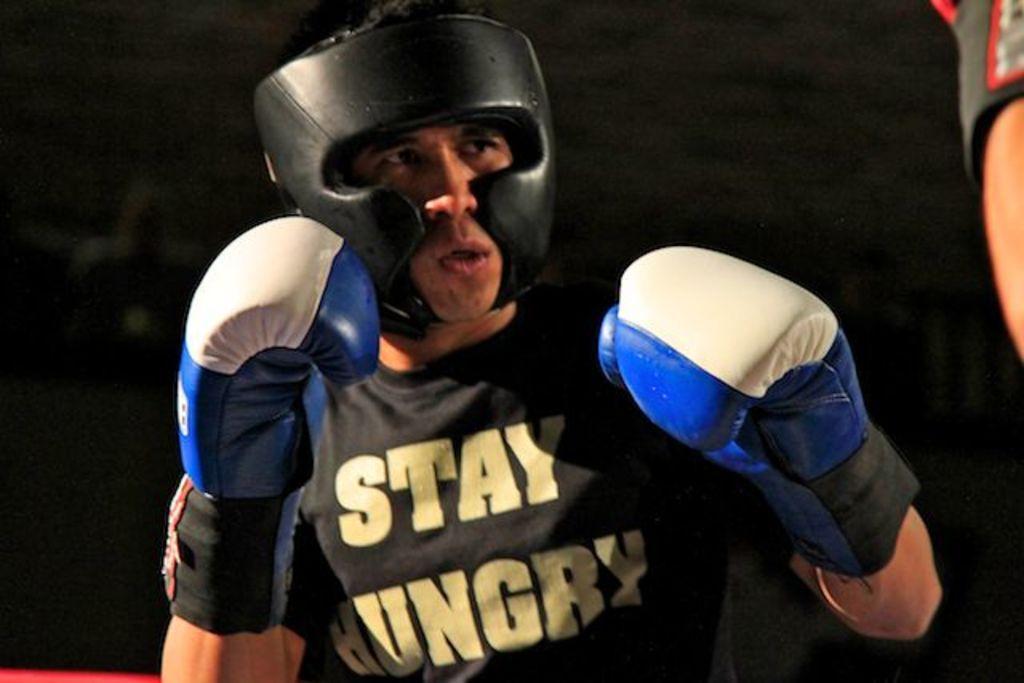Please provide a concise description of this image. In the center of the image there is a person wearing helmet and gloves. On the right side of the image there is a human hand. 